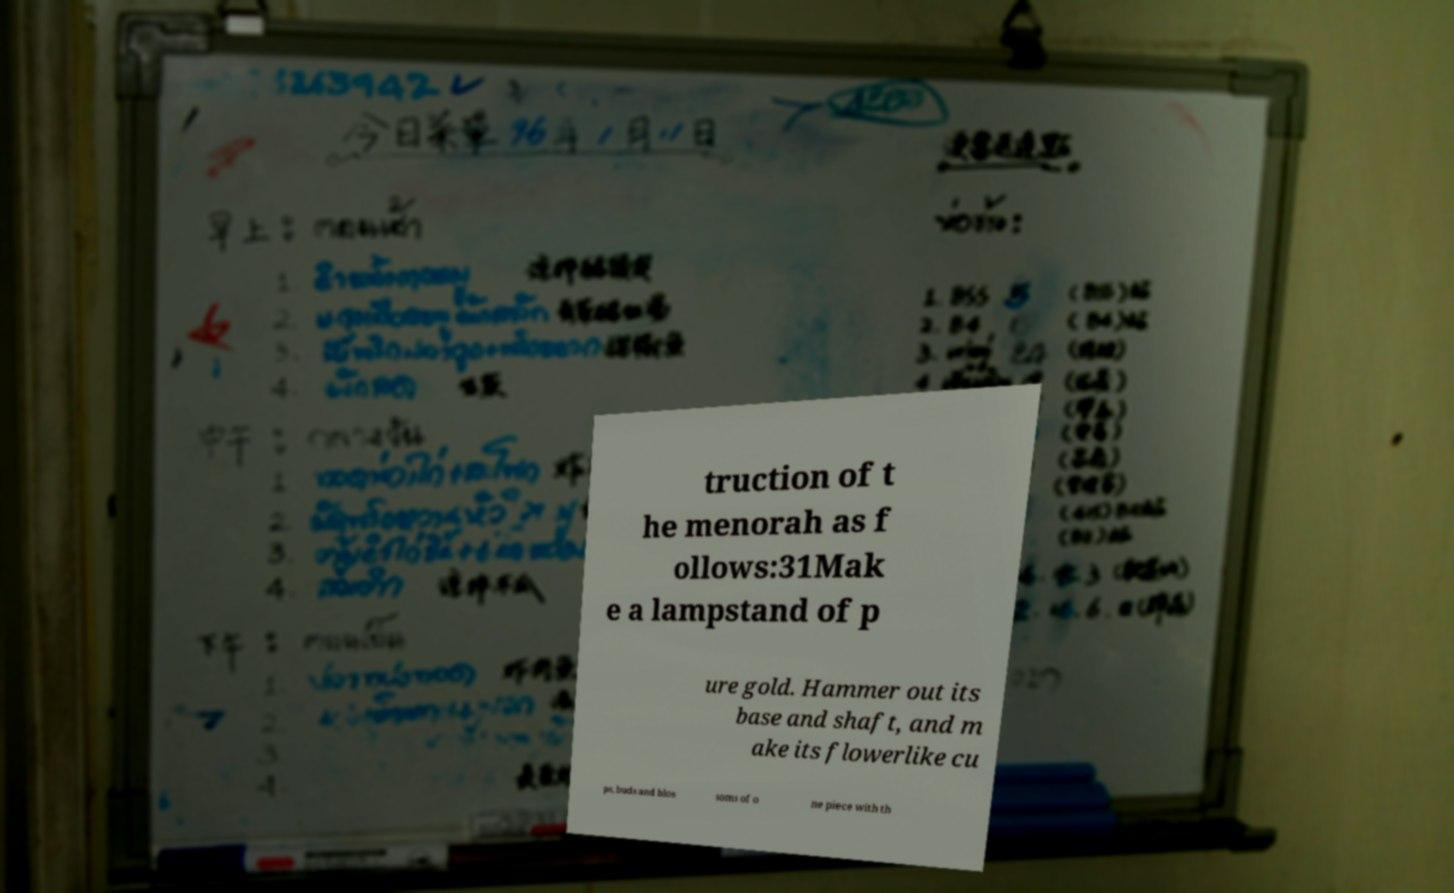I need the written content from this picture converted into text. Can you do that? truction of t he menorah as f ollows:31Mak e a lampstand of p ure gold. Hammer out its base and shaft, and m ake its flowerlike cu ps, buds and blos soms of o ne piece with th 